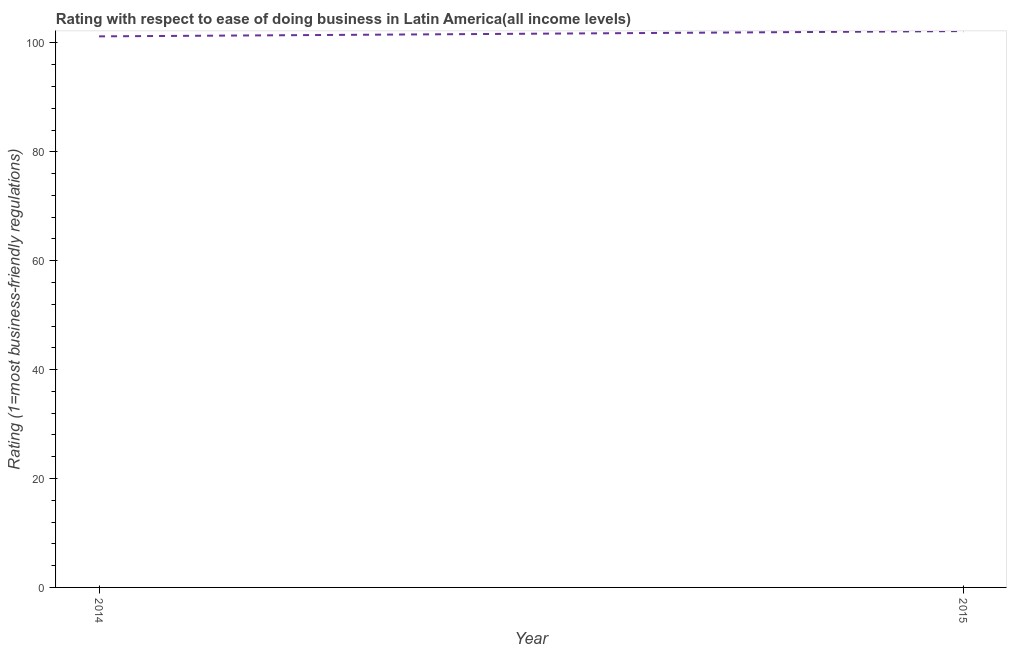What is the ease of doing business index in 2014?
Provide a short and direct response. 101.21. Across all years, what is the maximum ease of doing business index?
Provide a succinct answer. 102.18. Across all years, what is the minimum ease of doing business index?
Keep it short and to the point. 101.21. In which year was the ease of doing business index maximum?
Your answer should be compact. 2015. In which year was the ease of doing business index minimum?
Ensure brevity in your answer.  2014. What is the sum of the ease of doing business index?
Provide a succinct answer. 203.39. What is the difference between the ease of doing business index in 2014 and 2015?
Offer a terse response. -0.97. What is the average ease of doing business index per year?
Make the answer very short. 101.7. What is the median ease of doing business index?
Give a very brief answer. 101.7. What is the ratio of the ease of doing business index in 2014 to that in 2015?
Ensure brevity in your answer.  0.99. In how many years, is the ease of doing business index greater than the average ease of doing business index taken over all years?
Offer a terse response. 1. Does the ease of doing business index monotonically increase over the years?
Offer a terse response. Yes. How many years are there in the graph?
Offer a very short reply. 2. What is the difference between two consecutive major ticks on the Y-axis?
Your answer should be compact. 20. Does the graph contain grids?
Provide a short and direct response. No. What is the title of the graph?
Your response must be concise. Rating with respect to ease of doing business in Latin America(all income levels). What is the label or title of the Y-axis?
Give a very brief answer. Rating (1=most business-friendly regulations). What is the Rating (1=most business-friendly regulations) of 2014?
Provide a short and direct response. 101.21. What is the Rating (1=most business-friendly regulations) in 2015?
Offer a terse response. 102.18. What is the difference between the Rating (1=most business-friendly regulations) in 2014 and 2015?
Provide a succinct answer. -0.97. What is the ratio of the Rating (1=most business-friendly regulations) in 2014 to that in 2015?
Your answer should be very brief. 0.99. 